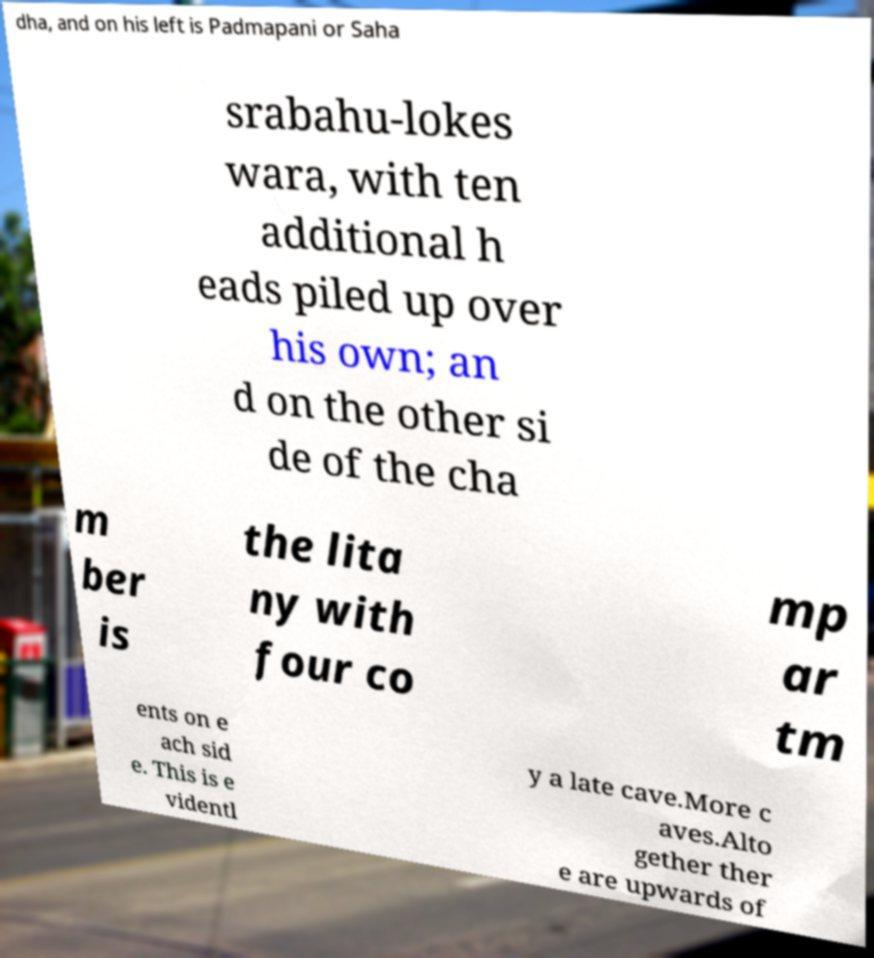There's text embedded in this image that I need extracted. Can you transcribe it verbatim? dha, and on his left is Padmapani or Saha srabahu-lokes wara, with ten additional h eads piled up over his own; an d on the other si de of the cha m ber is the lita ny with four co mp ar tm ents on e ach sid e. This is e videntl y a late cave.More c aves.Alto gether ther e are upwards of 